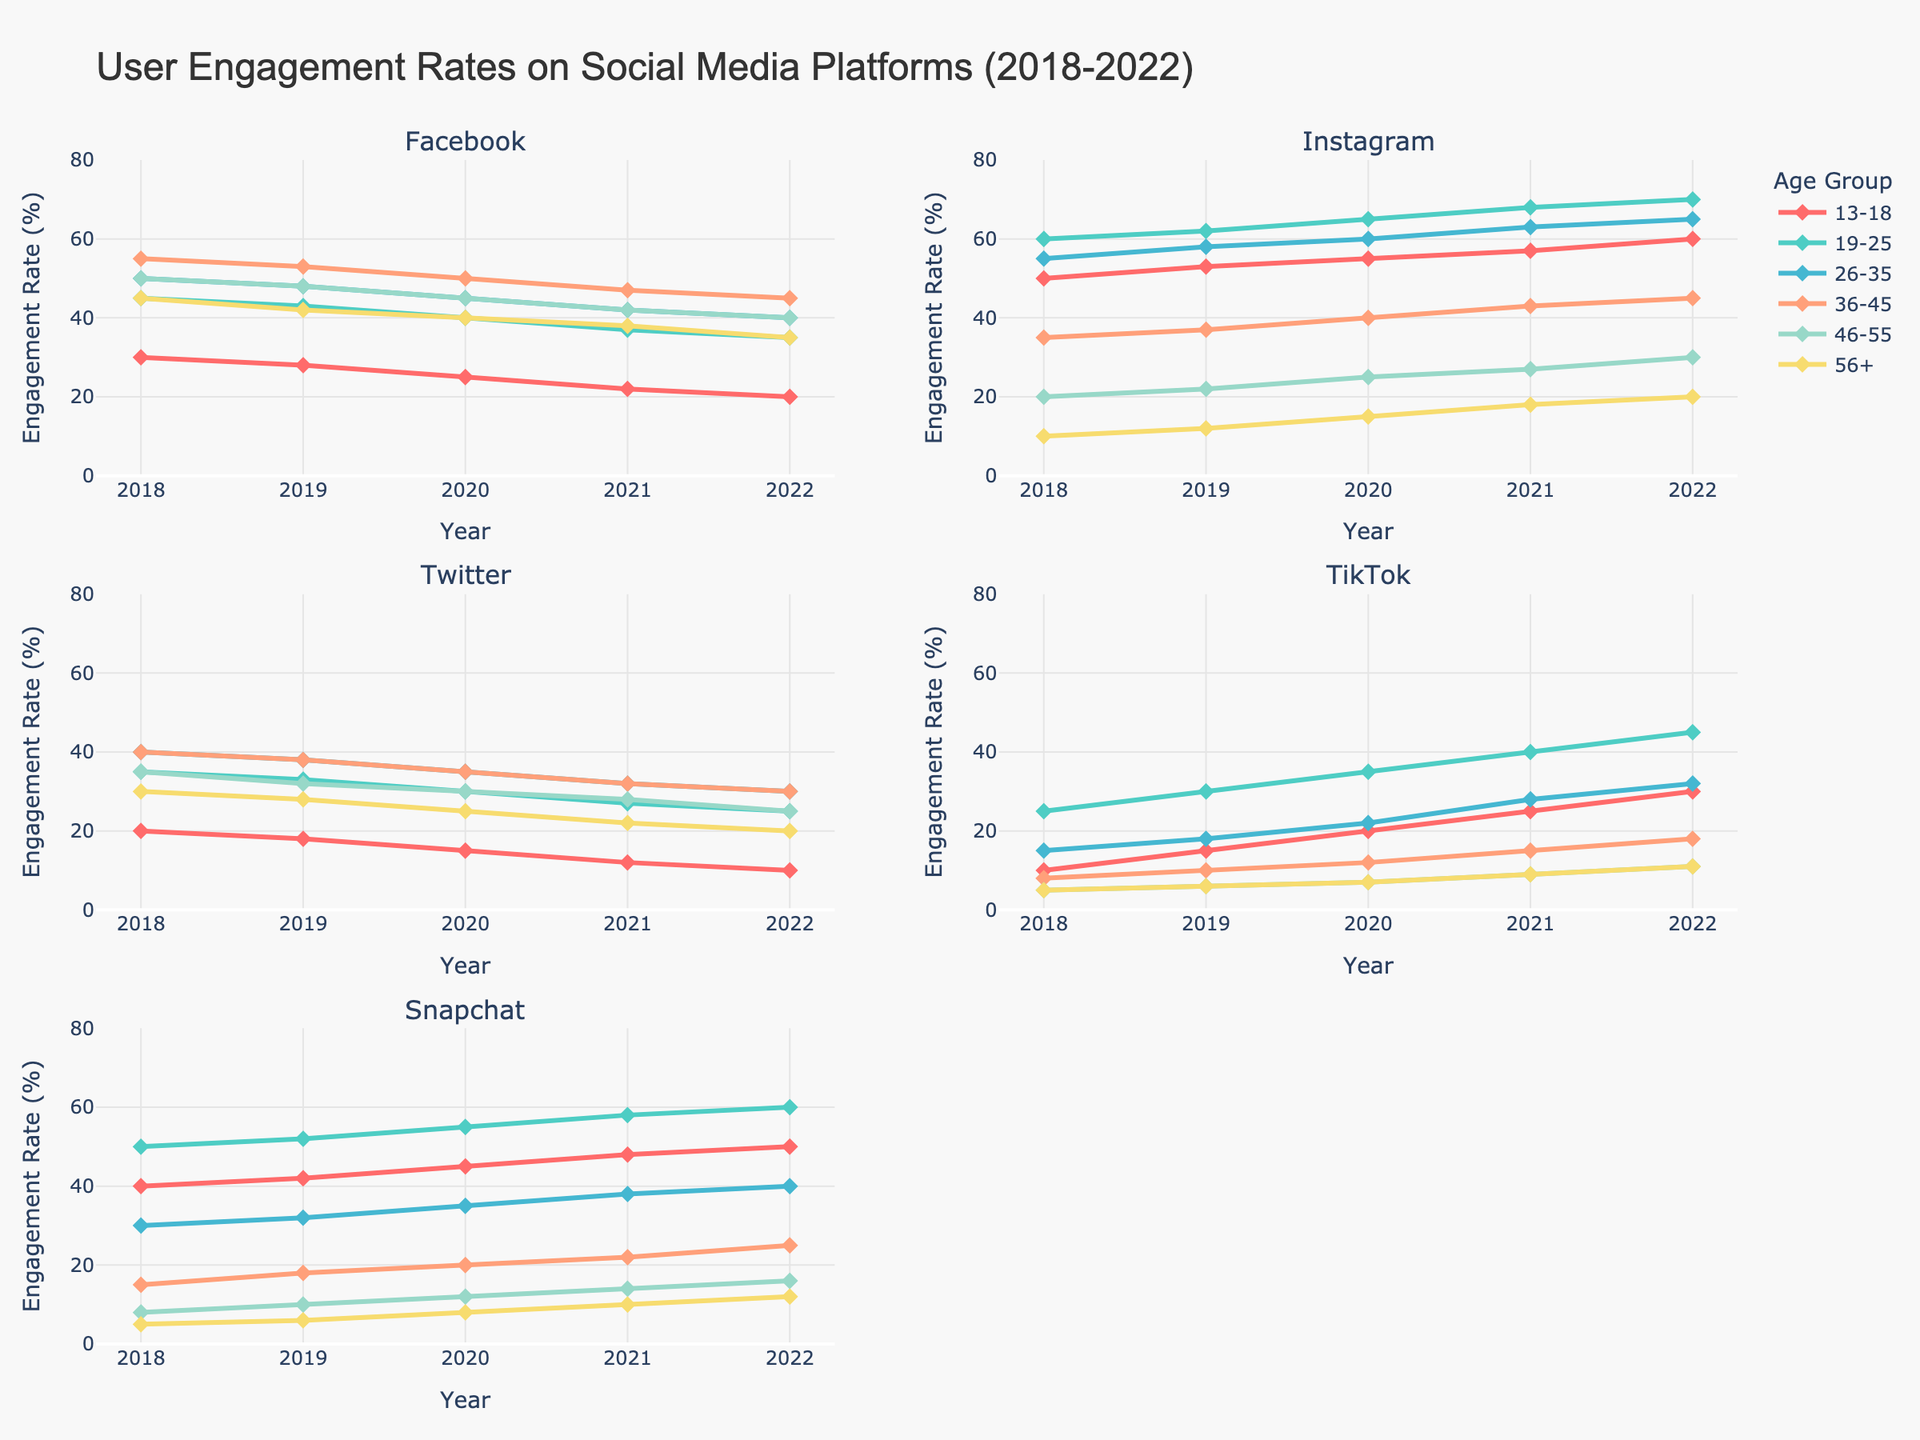what is the overall title of the plot? The title is located at the top of the figure and provides a summary of the content. It helps viewers quickly understand what the graph represents.
Answer: User Engagement Rates on Social Media Platforms (2018-2022) how many different social media platforms are tracked in this figure? The subplot titles represent individual social media platforms. By counting all the subplot titles, we can determine the number of platforms tracked.
Answer: 5 which age group shows the highest engagement rate for TikTok in 2022? Looking at the TikTok subplot, we compare the engagement rates of different age groups for the year 2022 and identify the highest one.
Answer: 19-25 how does the engagement rate for Instagram for the age group 13-18 change from 2018 to 2022? To find the trend, we locate the line corresponding to the 13-18 age group in the Instagram subplot and observe its changes over the years. Increases and decreases are noted.
Answer: It increases from 50% in 2018 to 60% in 2022 compare the engagement rates of the 26-35 age group on Facebook and Twitter in 2020. which one is higher? We look at the engagement rates of the 26-35 age group in 2020 on both the Facebook and Twitter subplots. By comparing these two values, we identify the higher one.
Answer: Facebook which social media platform has the lowest overall engagement rate for the age group 56+ in 2021? By examining the lowest points on the 2021 timeline in each subplot for the age group 56+, we can determine which platform has the lowest engagement rate.
Answer: Snapchat what is the trend for Snapchat engagement among the 36-45 age group over the 5 years? We follow the line representing the 36-45 age group in the Snapchat subplot from 2018 to 2022 and describe any increases, decreases, or stability in the engagement rate.
Answer: Incremental increase from 15% in 2018 to 25% in 2022 identify the year where the combined engagement rate of the age group 46-55 on all platforms is the highest. For each year, we sum the engagement rates of the age group 46-55 across all platforms and then compare these sums to identify the year with the highest combined engagement rate.
Answer: 2018 which age group consistently shows a decline in Twitter engagement over the years? By examining the Twitter subplot, we track the trend lines for each age group from 2018 to 2022 and identify the one with a consistent downward trend.
Answer: 13-18 among all platforms, for which does the age group 19-25 show the most dramatic increase in engagement rate from 2018 to 2022? By comparing the 2018 vs. 2022 differences in engagement rates for the 19-25 age group across all platforms, we determine where the sharpest increase occurs.
Answer: Instagram 